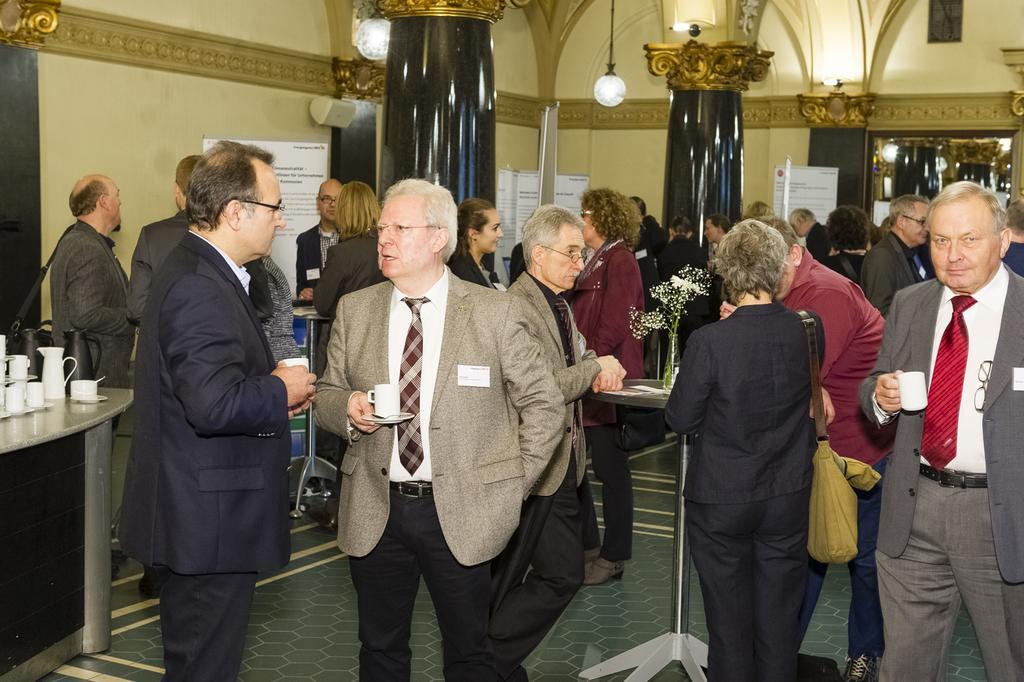How would you summarize this image in a sentence or two? In this image we can see some group of persons men wearing suits, women wearing blazer standing and most of them are holding coffee glass in their hands, on left side of the image there are some coffee cups, mugs which are on table and in the background of the image there are some pillars, lights, boards and there is a wall. 